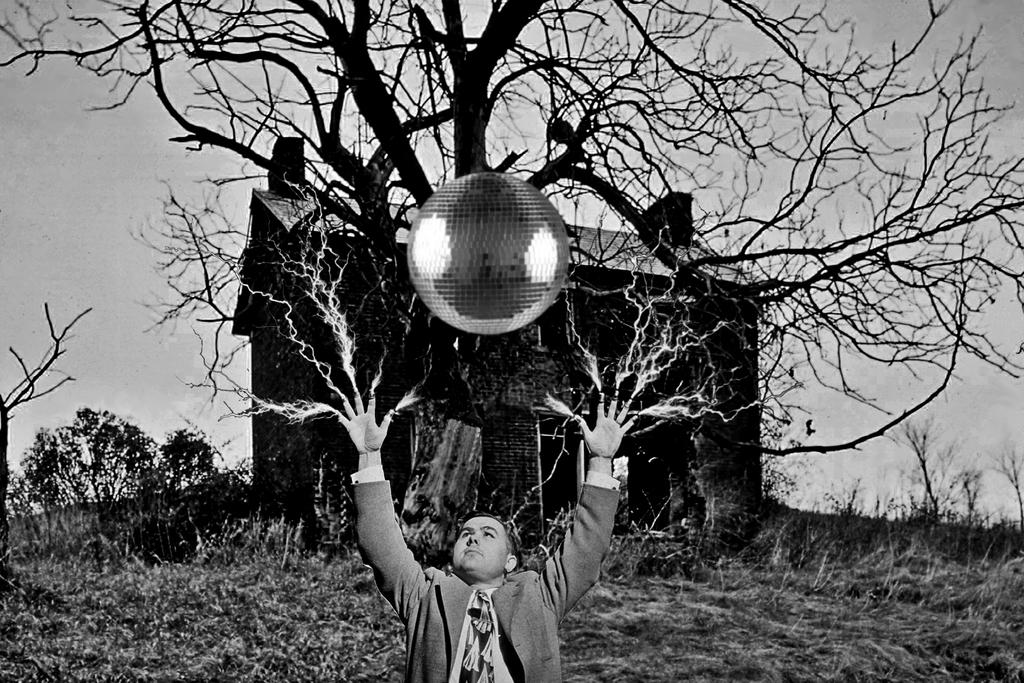What is the color scheme of the image? The image is black and white. What activity is the person in the image engaged in? The person is playing with a ball in the image. What can be seen in the background of the image? There is a building, a tree, and plants in the background of the image. What type of celery is being used as a prop in the image? There is no celery present in the image. What kind of structure is being built by the person in the image? The person in the image is playing with a ball, not building a structure. 